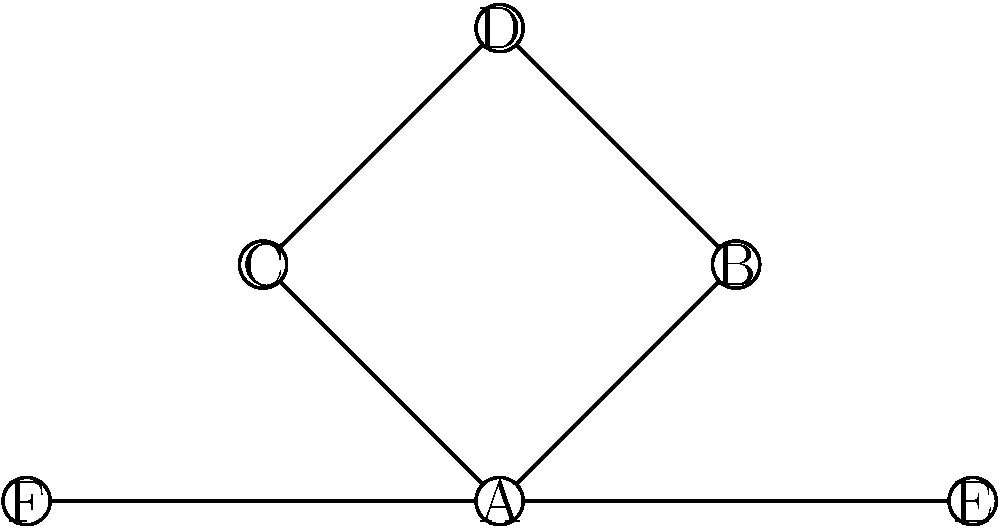In the interfaith dialogue network represented by the graph above, where each node represents a different religious community and edges represent established dialogues, what is the minimum number of additional edges needed to ensure that every community can reach every other community through the network? To solve this problem, we need to analyze the current connectivity of the graph and determine how many additional edges are required to make it fully connected. Let's follow these steps:

1. Identify the current connected components:
   - Component 1: A, B, C, D, E, F (all nodes are in one component)

2. Count the number of nodes (n) and edges (e):
   - n = 6 (A, B, C, D, E, F)
   - e = 7 (AB, AC, AE, AF, BD, CD, EF)

3. Calculate the minimum number of edges needed for a fully connected graph:
   - In a fully connected graph with n nodes, the number of edges is given by the formula: $$\frac{n(n-1)}{2}$$
   - For 6 nodes, this would be: $$\frac{6(6-1)}{2} = \frac{6 \times 5}{2} = 15$$ edges

4. Calculate the number of additional edges needed:
   - Additional edges = Minimum edges for full connectivity - Current edges
   - $$15 - 7 = 8$$ additional edges

Therefore, the minimum number of additional edges needed to ensure that every community can reach every other community through the network is 8.
Answer: 8 